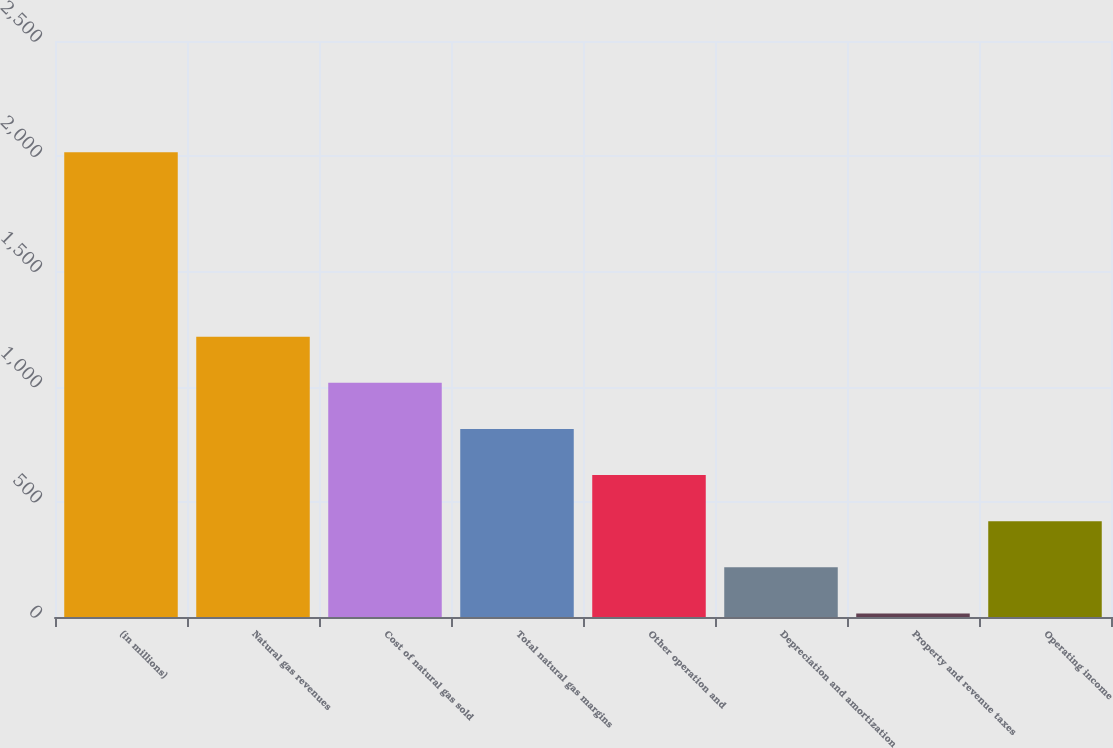Convert chart to OTSL. <chart><loc_0><loc_0><loc_500><loc_500><bar_chart><fcel>(in millions)<fcel>Natural gas revenues<fcel>Cost of natural gas sold<fcel>Total natural gas margins<fcel>Other operation and<fcel>Depreciation and amortization<fcel>Property and revenue taxes<fcel>Operating income<nl><fcel>2017<fcel>1216.44<fcel>1016.3<fcel>816.16<fcel>616.02<fcel>215.74<fcel>15.6<fcel>415.88<nl></chart> 